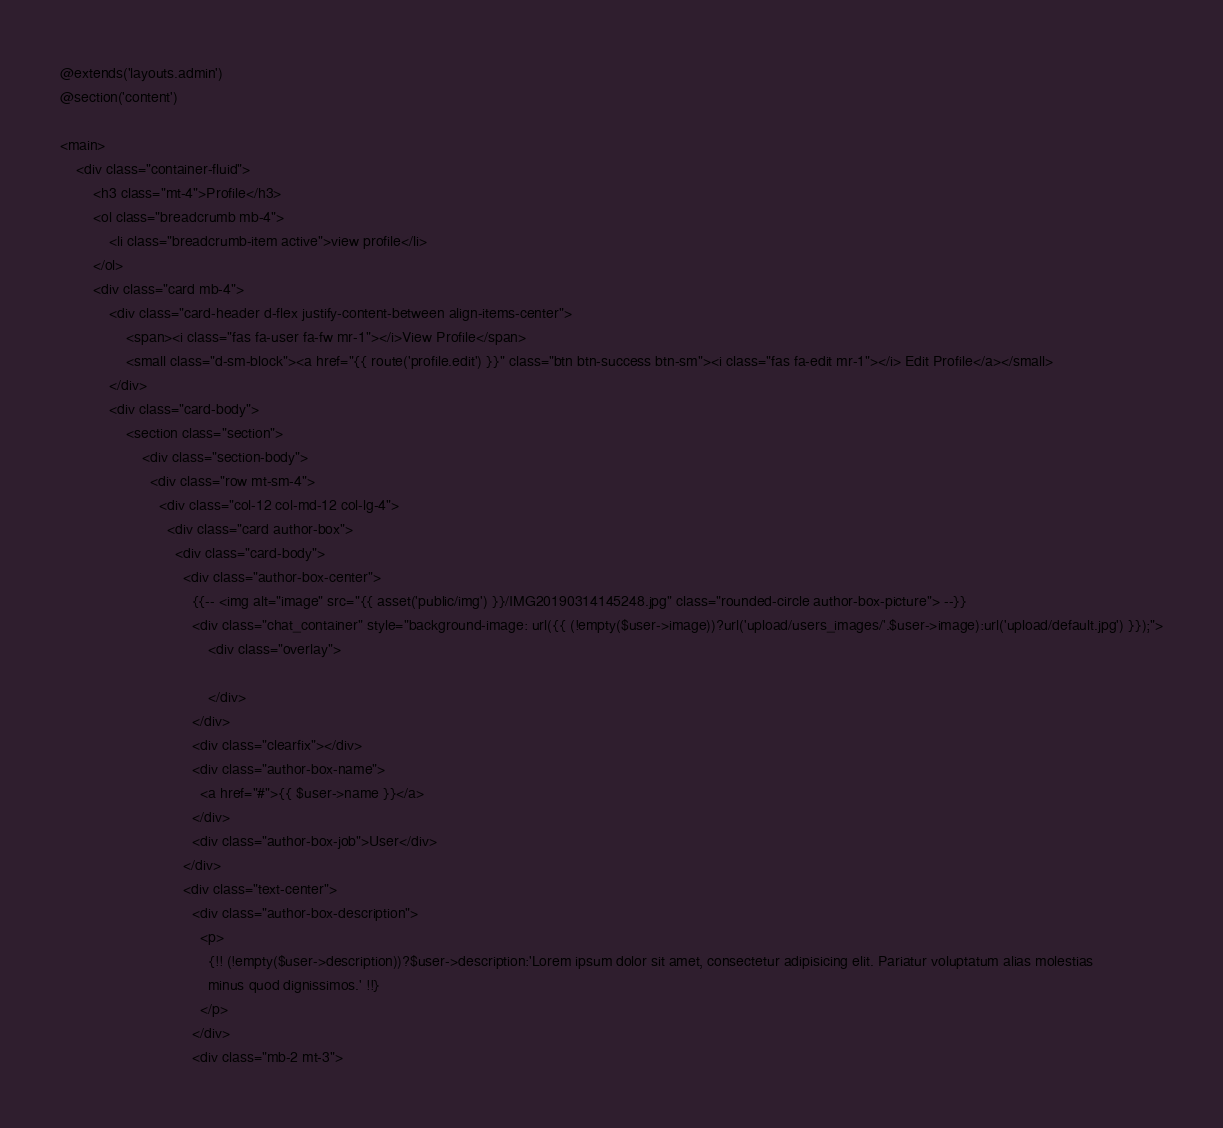<code> <loc_0><loc_0><loc_500><loc_500><_PHP_>@extends('layouts.admin')
@section('content')

<main>
    <div class="container-fluid">
        <h3 class="mt-4">Profile</h3>
        <ol class="breadcrumb mb-4">
            <li class="breadcrumb-item active">view profile</li>
        </ol>
        <div class="card mb-4">
            <div class="card-header d-flex justify-content-between align-items-center">
                <span><i class="fas fa-user fa-fw mr-1"></i>View Profile</span>
                <small class="d-sm-block"><a href="{{ route('profile.edit') }}" class="btn btn-success btn-sm"><i class="fas fa-edit mr-1"></i> Edit Profile</a></small>
            </div>
            <div class="card-body">
                <section class="section">
                    <div class="section-body">
                      <div class="row mt-sm-4">
                        <div class="col-12 col-md-12 col-lg-4">
                          <div class="card author-box">
                            <div class="card-body">
                              <div class="author-box-center">
                                {{-- <img alt="image" src="{{ asset('public/img') }}/IMG20190314145248.jpg" class="rounded-circle author-box-picture"> --}}
                                <div class="chat_container" style="background-image: url({{ (!empty($user->image))?url('upload/users_images/'.$user->image):url('upload/default.jpg') }});">
                                    <div class="overlay">
                                        
                                    </div>
                                </div>
                                <div class="clearfix"></div>
                                <div class="author-box-name">
                                  <a href="#">{{ $user->name }}</a>
                                </div>
                                <div class="author-box-job">User</div>
                              </div>
                              <div class="text-center">
                                <div class="author-box-description">
                                  <p>
                                    {!! (!empty($user->description))?$user->description:'Lorem ipsum dolor sit amet, consectetur adipisicing elit. Pariatur voluptatum alias molestias
                                    minus quod dignissimos.' !!}
                                  </p>
                                </div>
                                <div class="mb-2 mt-3"></code> 